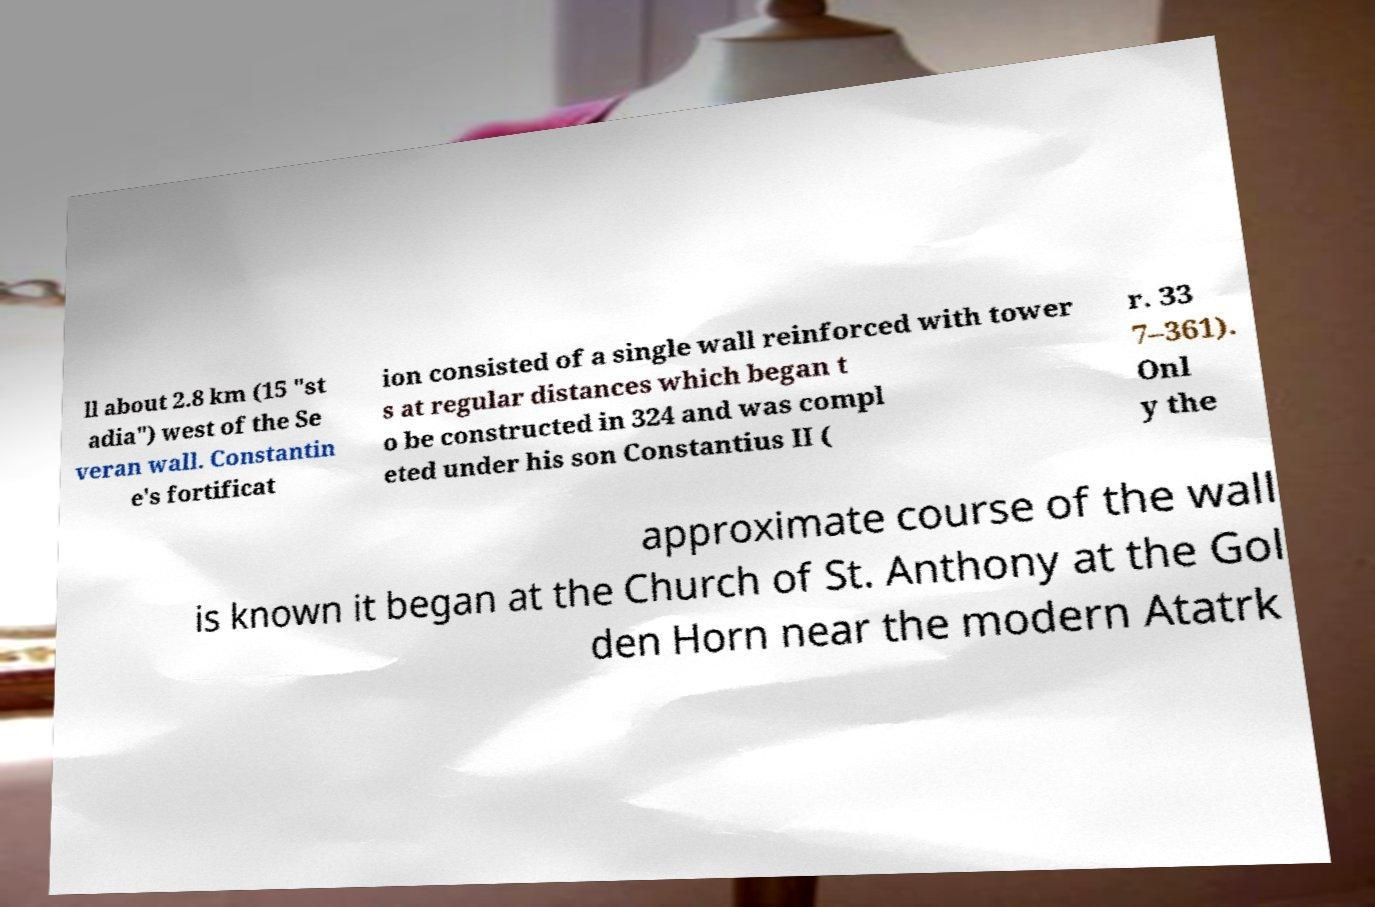Please identify and transcribe the text found in this image. ll about 2.8 km (15 "st adia") west of the Se veran wall. Constantin e's fortificat ion consisted of a single wall reinforced with tower s at regular distances which began t o be constructed in 324 and was compl eted under his son Constantius II ( r. 33 7–361). Onl y the approximate course of the wall is known it began at the Church of St. Anthony at the Gol den Horn near the modern Atatrk 